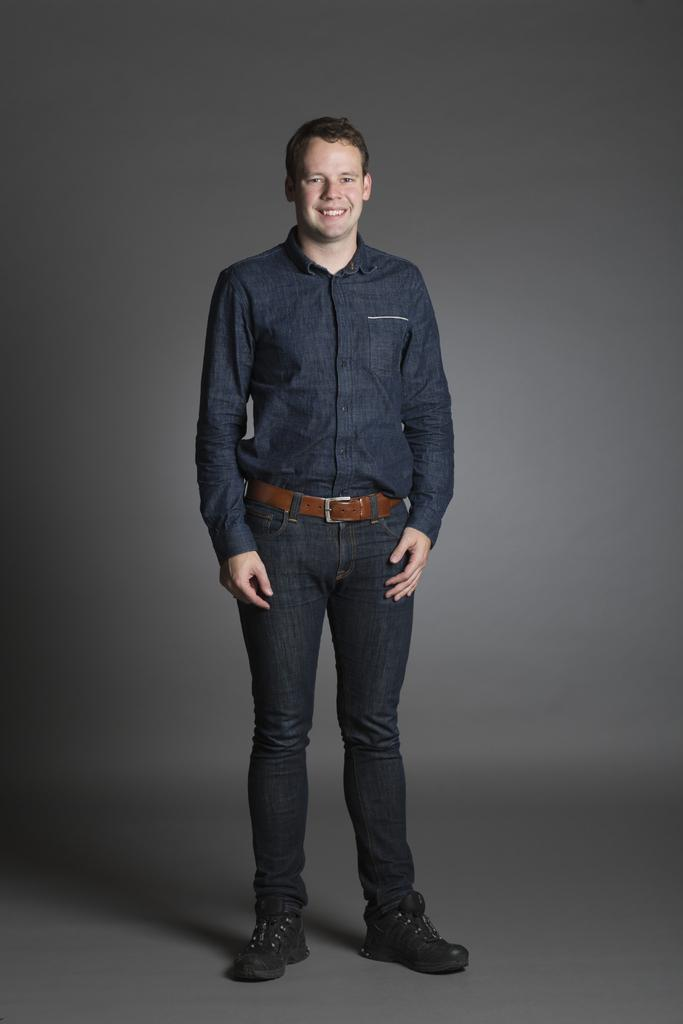What is the man in the image doing? The man is standing in the image. What is the man's facial expression? The man is smiling. What type of clothing is the man wearing on his upper body? The man is wearing a shirt. What color is the belt the man is wearing? The man is wearing a brown belt. What color are the man's jeans? The man is wearing black jeans. What type of footwear is the man wearing? The man is wearing black shoes. What is the color of the background in the image? The background of the image is grey in color. What year is the man taking the test in the image? There is no indication of a test or a specific year in the image. 